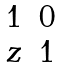<formula> <loc_0><loc_0><loc_500><loc_500>\begin{matrix} 1 & 0 \\ z & 1 \end{matrix}</formula> 